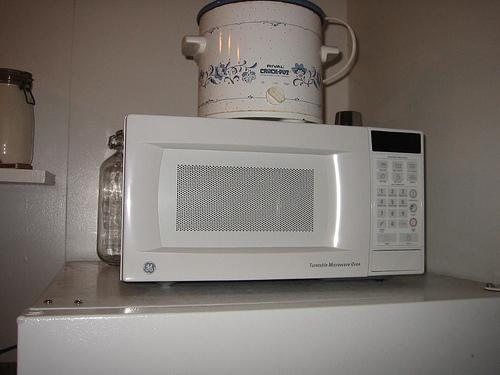Which object has a door that opens? Please explain your reasoning. microwave. The small appliance has a door for one to put the food in to heat it up. 